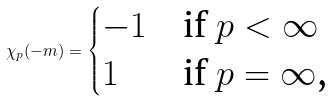<formula> <loc_0><loc_0><loc_500><loc_500>\chi _ { p } ( - m ) = \begin{cases} - 1 & \text {if $p<\infty$} \\ 1 & \text {if $p=\infty$,} \end{cases}</formula> 